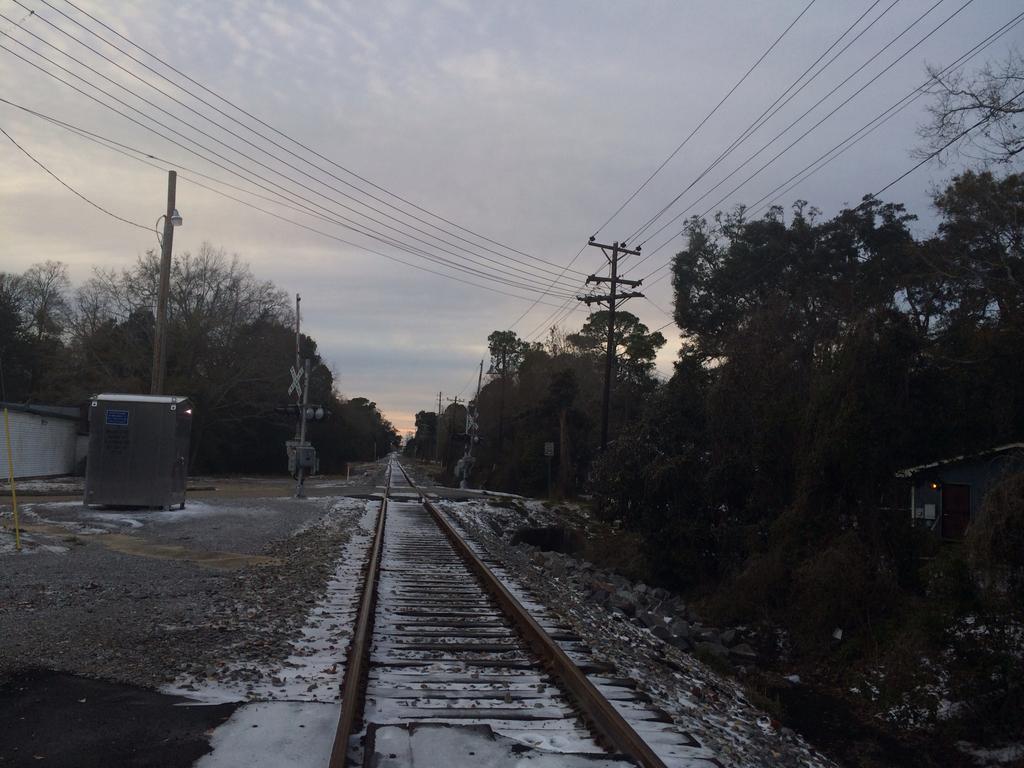Could you give a brief overview of what you see in this image? In this image there is railway track, pants, poles,snow, trees, and in the background there is sky. 